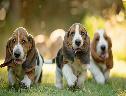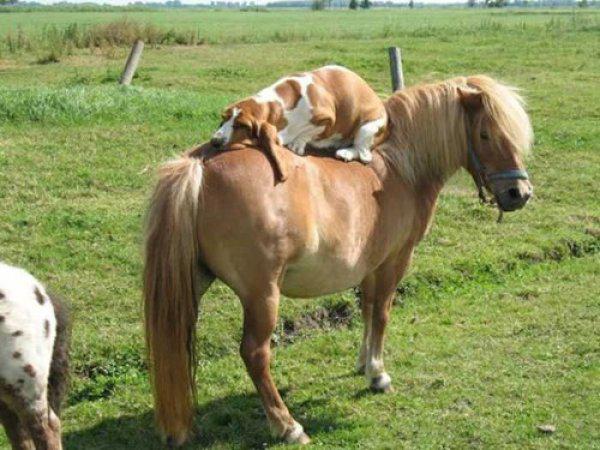The first image is the image on the left, the second image is the image on the right. For the images displayed, is the sentence "One image shows exactly two basset hounds." factually correct? Answer yes or no. No. 